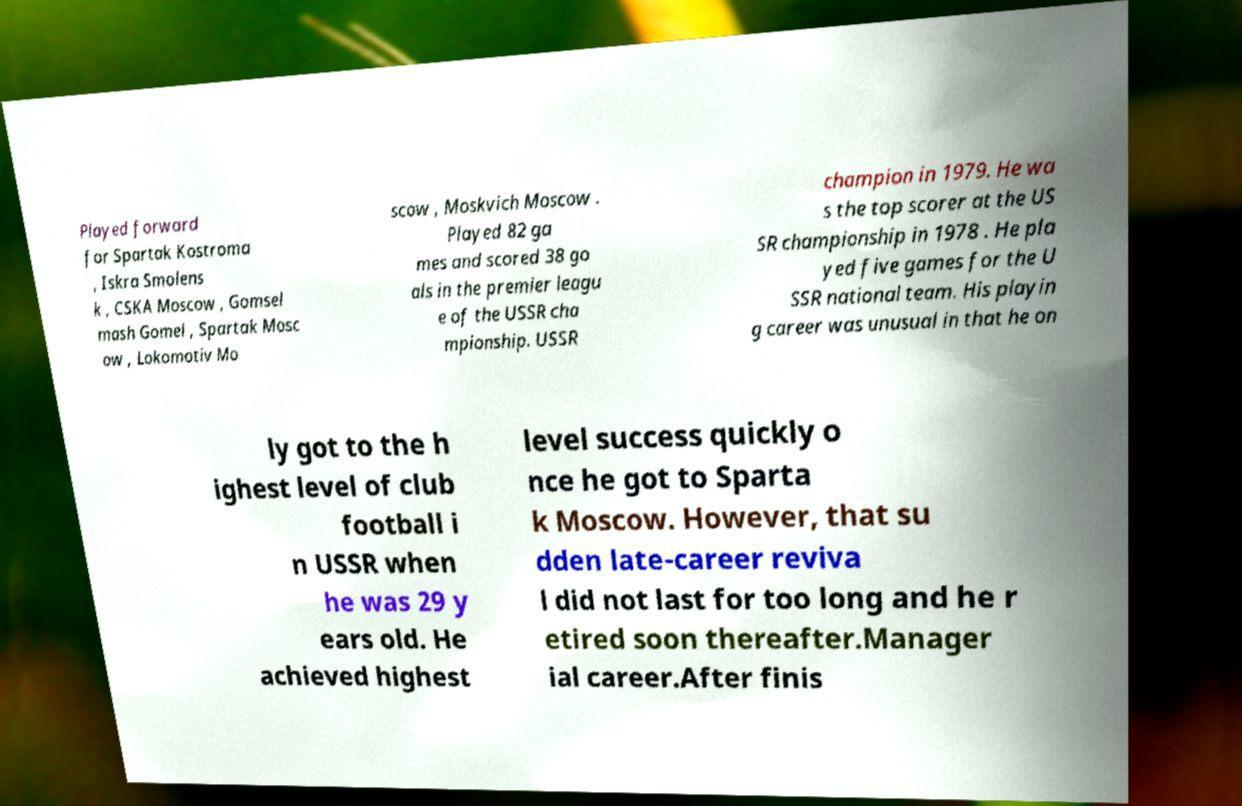Can you accurately transcribe the text from the provided image for me? Played forward for Spartak Kostroma , Iskra Smolens k , CSKA Moscow , Gomsel mash Gomel , Spartak Mosc ow , Lokomotiv Mo scow , Moskvich Moscow . Played 82 ga mes and scored 38 go als in the premier leagu e of the USSR cha mpionship. USSR champion in 1979. He wa s the top scorer at the US SR championship in 1978 . He pla yed five games for the U SSR national team. His playin g career was unusual in that he on ly got to the h ighest level of club football i n USSR when he was 29 y ears old. He achieved highest level success quickly o nce he got to Sparta k Moscow. However, that su dden late-career reviva l did not last for too long and he r etired soon thereafter.Manager ial career.After finis 